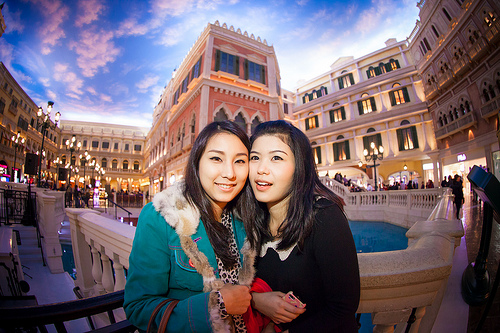<image>
Can you confirm if the women is behind the pool? No. The women is not behind the pool. From this viewpoint, the women appears to be positioned elsewhere in the scene. 